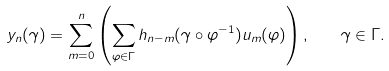<formula> <loc_0><loc_0><loc_500><loc_500>y _ { n } ( \gamma ) = \sum _ { m = 0 } ^ { n } \left ( \sum _ { \varphi \in \Gamma } h _ { n - m } ( \gamma \circ \varphi ^ { - 1 } ) u _ { m } ( \varphi ) \right ) , \quad \gamma \in \Gamma .</formula> 